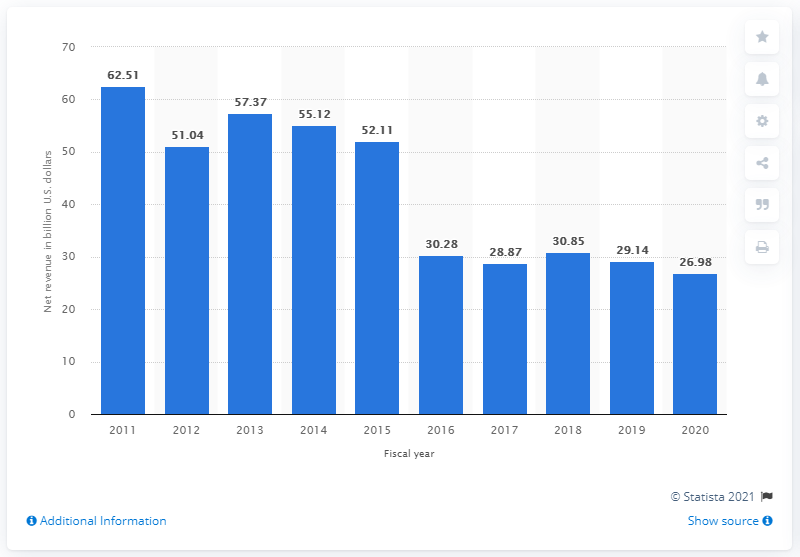Indicate a few pertinent items in this graphic. In 2020, HPE reported a revenue of 26.98 million dollars. The U.S. revenue for Hewlett Packard Enterprise in the previous year was 29.14. 